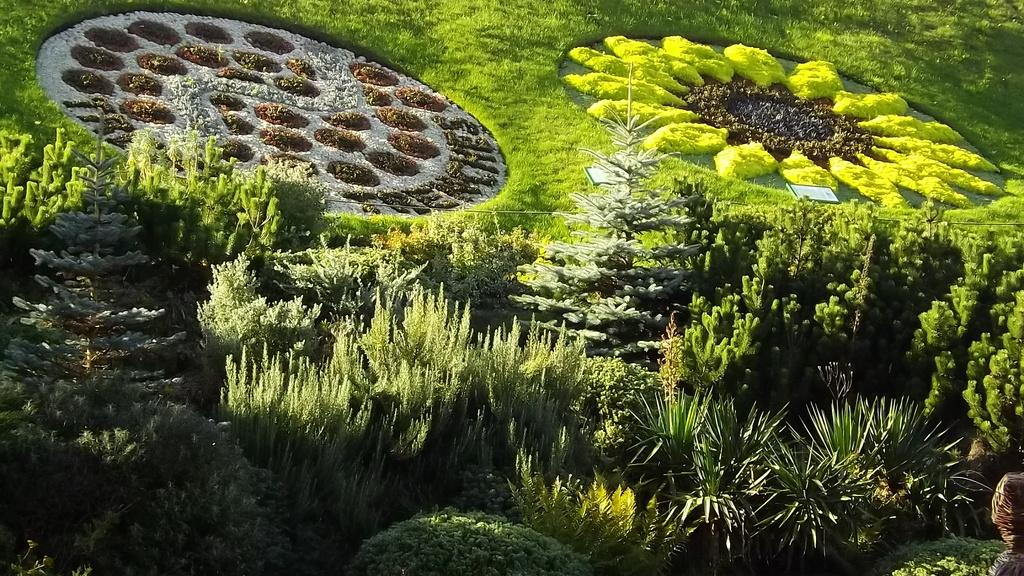What type of living organisms can be seen in the image? Plants can be seen in the image. What else is present in the image besides plants? There are garden arts in the image. Can you describe the person in the image? There is a person at the right bottom of the image. What type of pickle is the person holding in the image? There is no pickle present in the image; the person is not holding anything. 